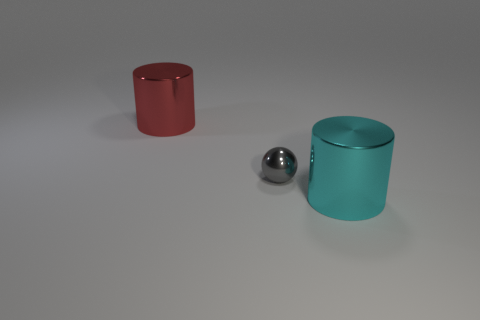There is a large object on the left side of the metal cylinder in front of the ball; what is its shape?
Offer a very short reply. Cylinder. What number of objects are either large cyan shiny cylinders or big cylinders that are in front of the big red metal thing?
Your answer should be compact. 1. What number of other objects are there of the same color as the ball?
Provide a succinct answer. 0. What number of red objects are either shiny balls or metallic things?
Offer a very short reply. 1. Is there a cylinder that is in front of the large metal cylinder behind the cyan cylinder that is to the right of the small sphere?
Offer a very short reply. Yes. Is there any other thing that is the same size as the shiny sphere?
Provide a succinct answer. No. What color is the big metallic object behind the large metal cylinder that is in front of the small gray ball?
Keep it short and to the point. Red. What number of big objects are either gray metal objects or shiny cylinders?
Provide a short and direct response. 2. The object that is to the left of the cyan metal thing and in front of the red cylinder is what color?
Ensure brevity in your answer.  Gray. What is the shape of the tiny gray metallic thing?
Provide a succinct answer. Sphere. 